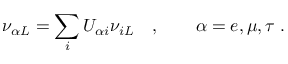Convert formula to latex. <formula><loc_0><loc_0><loc_500><loc_500>\nu _ { { \alpha } L } = \sum _ { i } U _ { { \alpha } i } \nu _ { i L } \quad , \quad \alpha = e , \mu , \tau \, .</formula> 